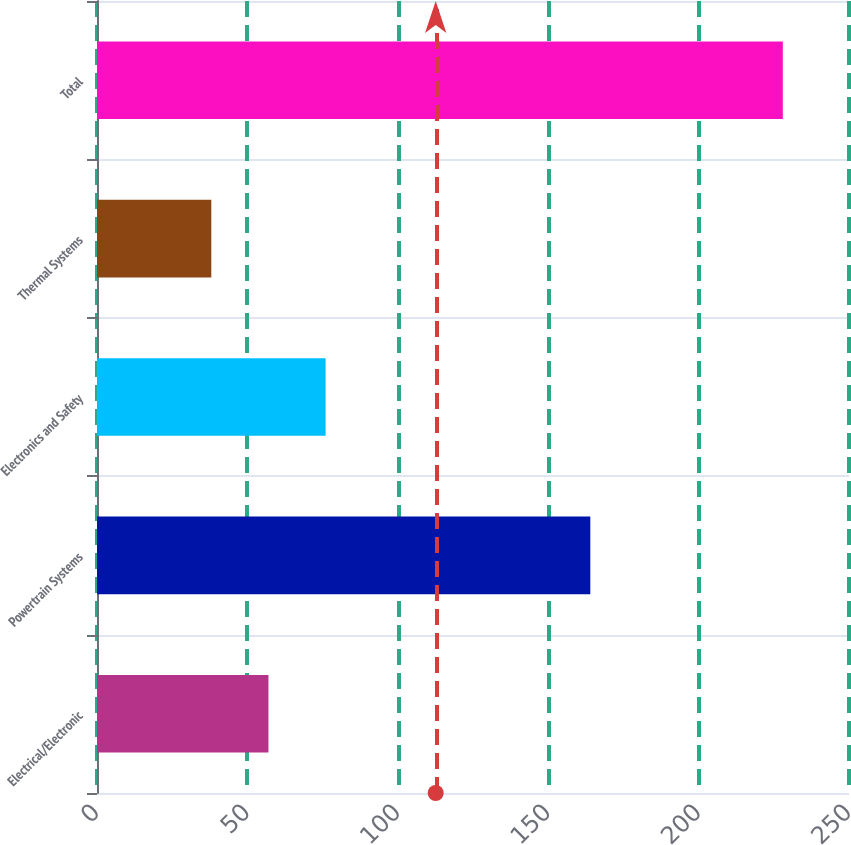<chart> <loc_0><loc_0><loc_500><loc_500><bar_chart><fcel>Electrical/Electronic<fcel>Powertrain Systems<fcel>Electronics and Safety<fcel>Thermal Systems<fcel>Total<nl><fcel>57<fcel>164<fcel>76<fcel>38<fcel>228<nl></chart> 